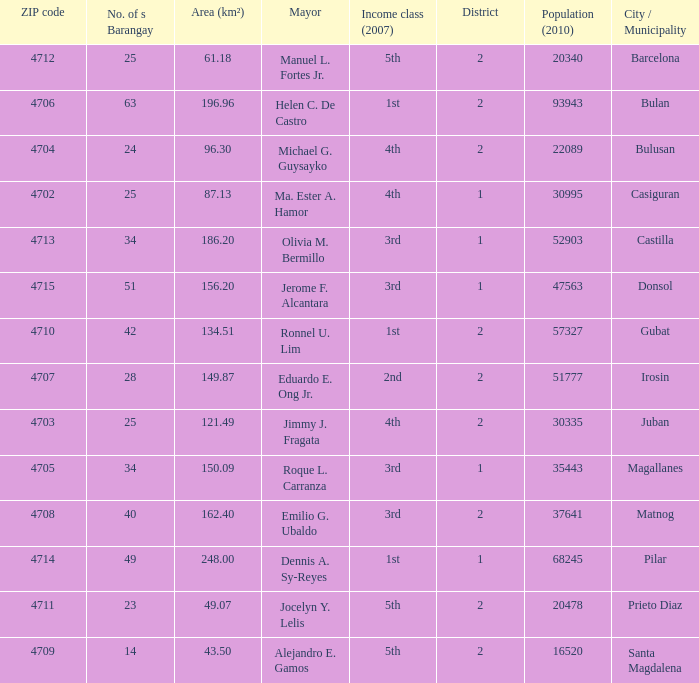What are all the profits elegance (2007) in which mayor is ma. Ester a. Hamor 4th. 